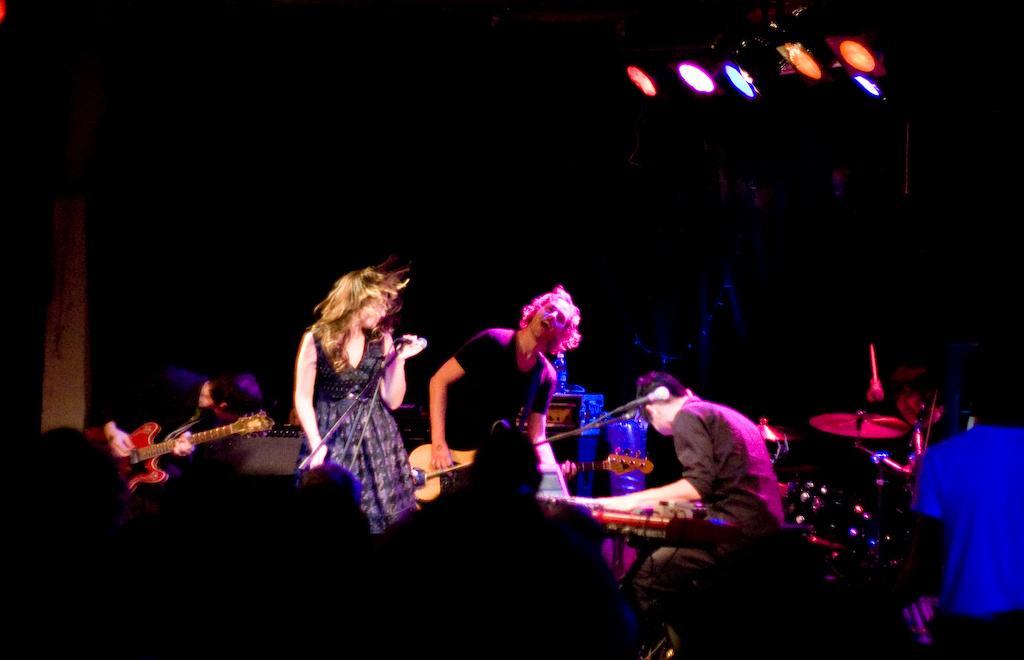Describe this image in one or two sentences. In this image there is a man in the middle who is playing the guitar. Beside him there is a woman who is holding the mic. On the right side there is a man who is playing the keyboard. On the left side there is another person who is playing the guitar. At the top there are lights. On the right side there are drums and musical plates. 